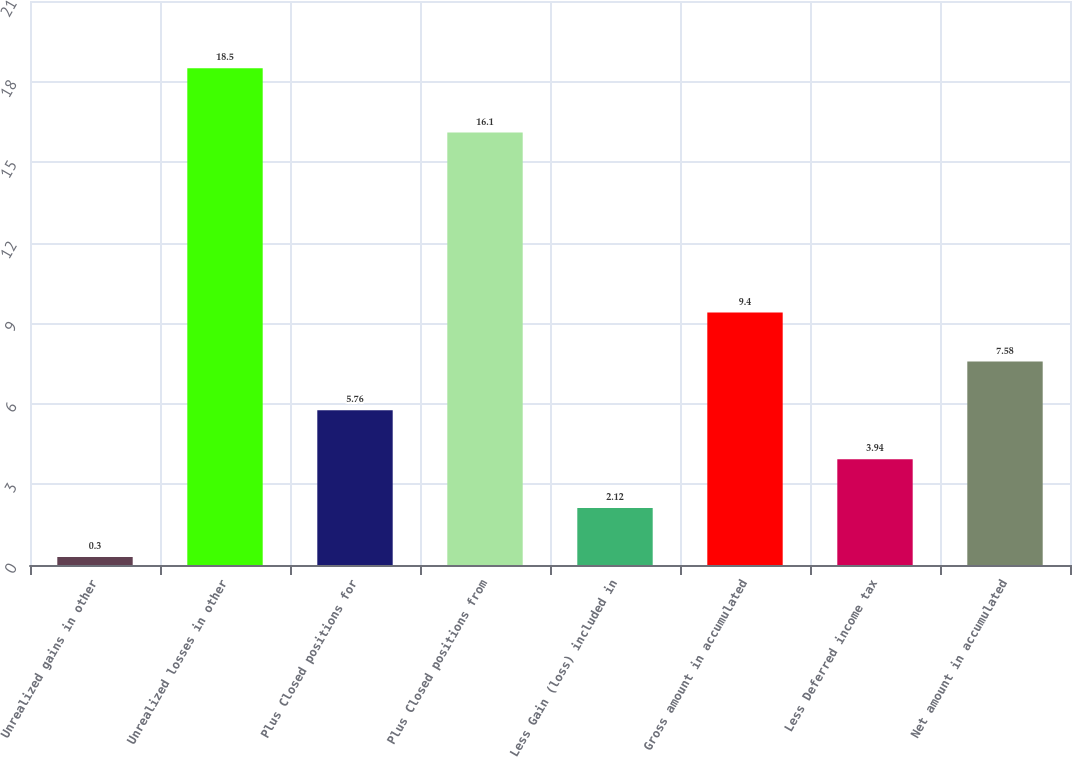Convert chart. <chart><loc_0><loc_0><loc_500><loc_500><bar_chart><fcel>Unrealized gains in other<fcel>Unrealized losses in other<fcel>Plus Closed positions for<fcel>Plus Closed positions from<fcel>Less Gain (loss) included in<fcel>Gross amount in accumulated<fcel>Less Deferred income tax<fcel>Net amount in accumulated<nl><fcel>0.3<fcel>18.5<fcel>5.76<fcel>16.1<fcel>2.12<fcel>9.4<fcel>3.94<fcel>7.58<nl></chart> 